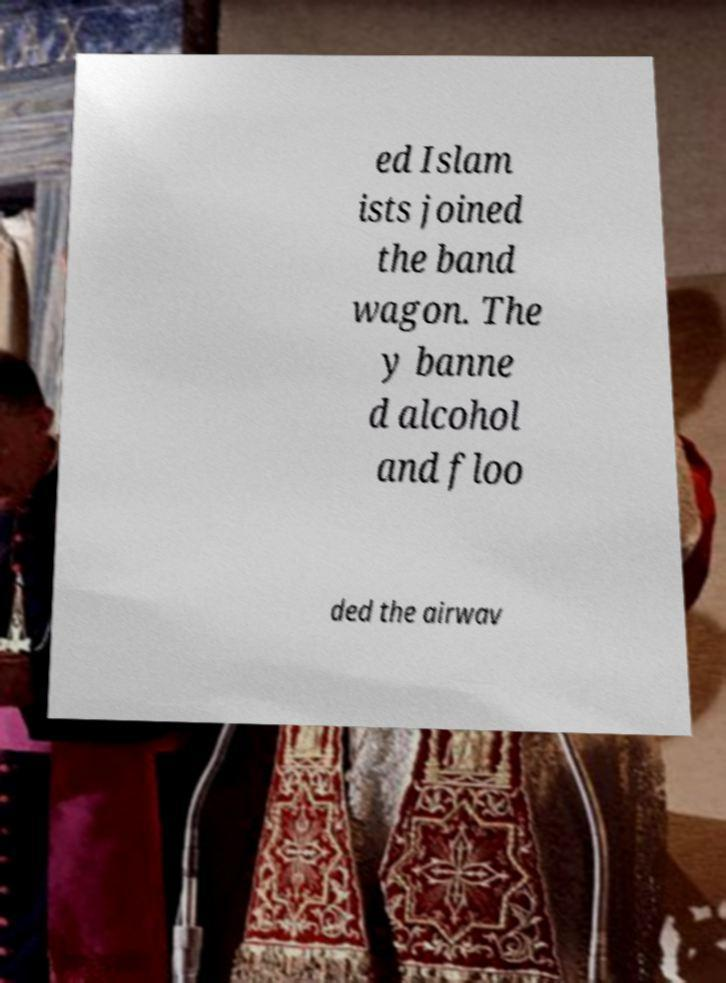What messages or text are displayed in this image? I need them in a readable, typed format. ed Islam ists joined the band wagon. The y banne d alcohol and floo ded the airwav 